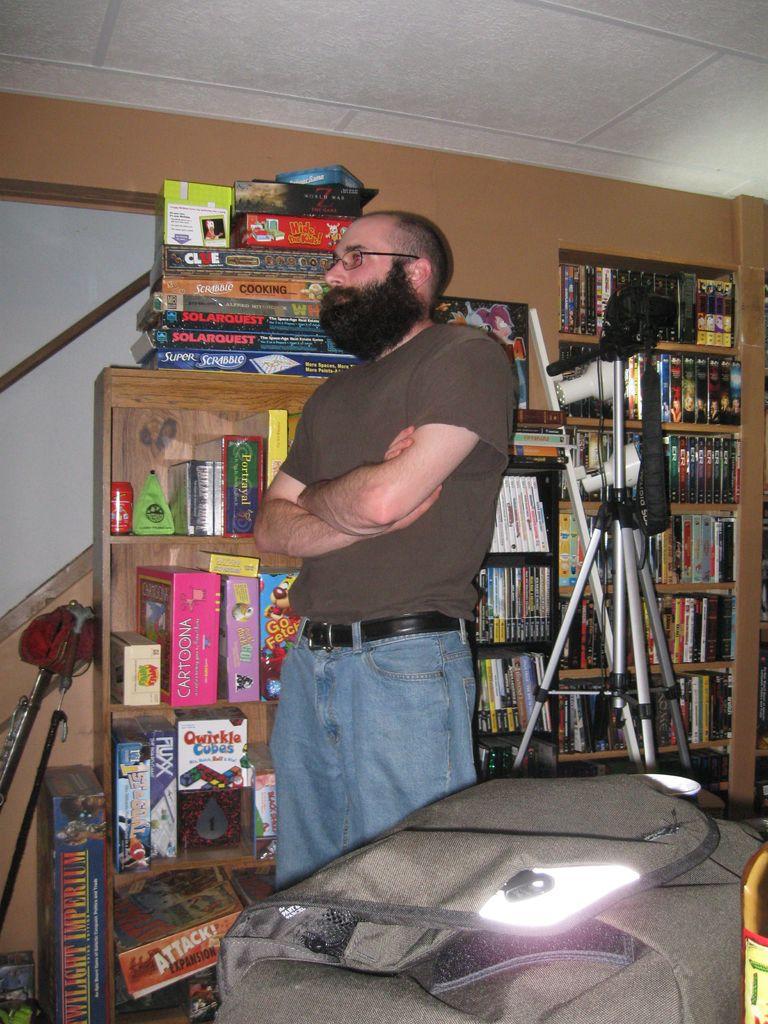What is the game on the floor on the left?
Ensure brevity in your answer.  Twilight imperium. What is in that pink box?
Your answer should be compact. Cartoona. 